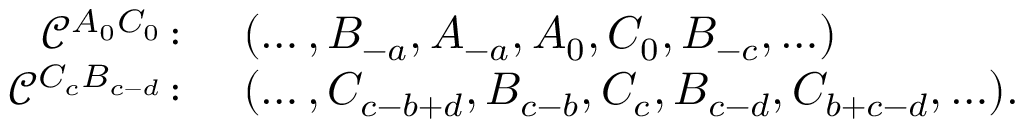<formula> <loc_0><loc_0><loc_500><loc_500>\begin{array} { r l } { \mathcal { C } ^ { A _ { 0 } C _ { 0 } } \colon } & { ( \dots , B _ { - a } , A _ { - a } , A _ { 0 } , C _ { 0 } , B _ { - c } , \dots ) } \\ { \mathcal { C } ^ { C _ { c } B _ { c - d } } \colon } & { ( \dots , C _ { c - b + d } , B _ { c - b } , C _ { c } , B _ { c - d } , C _ { b + c - d } , \dots ) . } \end{array}</formula> 